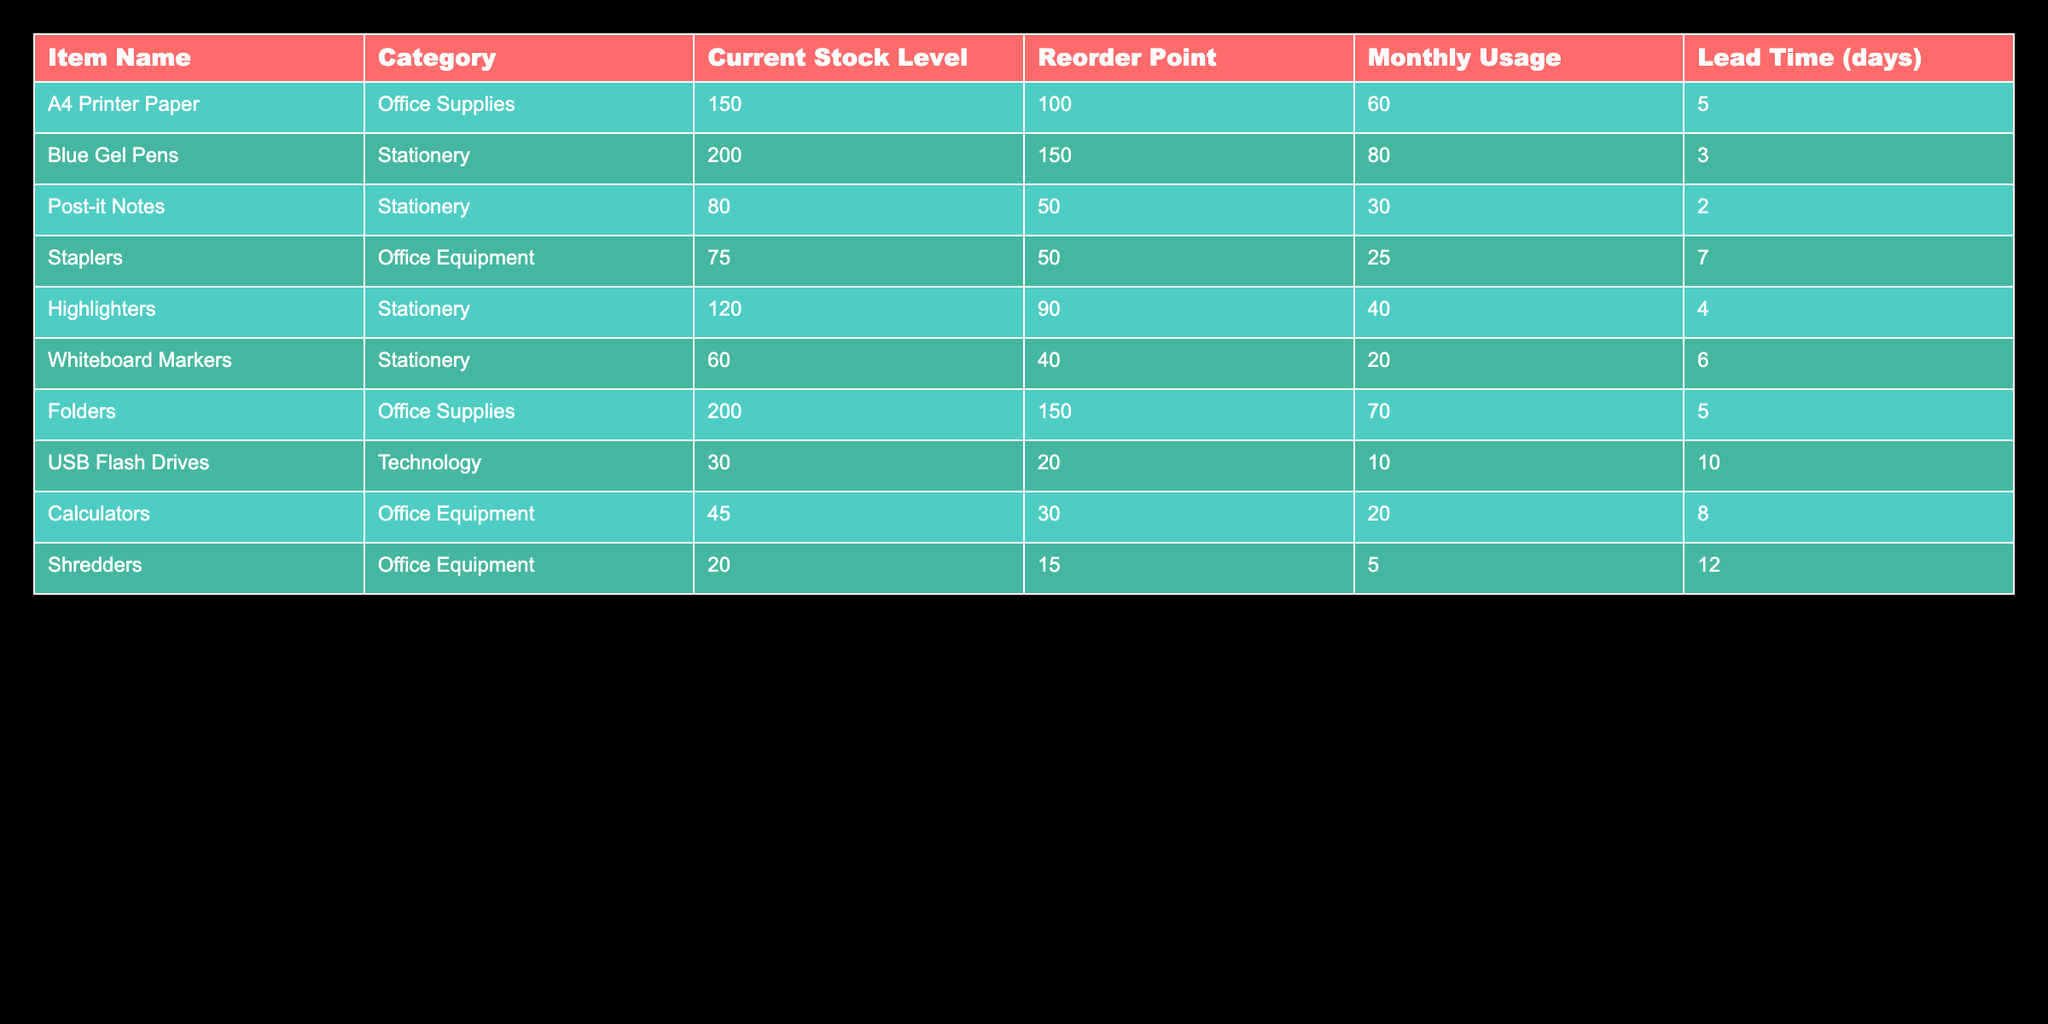What is the current stock level of Blue Gel Pens? The table lists Blue Gel Pens under the Item Name and shows the Current Stock Level in the corresponding column. The value there is 200.
Answer: 200 Is the current stock level of A4 Printer Paper above its reorder point? The current stock level for A4 Printer Paper is 150, and its reorder point is 100. Since 150 is greater than 100, it indicates that the stock level is above the reorder point.
Answer: Yes What is the total monthly usage of all Office Equipment items? There are three items categorized as Office Equipment: Staplers (25), Calculators (20), and Shredders (5). Adding them together gives total monthly usage: 25 + 20 + 5 = 50.
Answer: 50 How many items have a current stock level less than their reorder point? First, we check each item’s current stock level against its reorder point. Staplers (75 vs. 50), USB Flash Drives (30 vs. 20), Calculators (45 vs. 30), and Shredders (20 vs. 15) meet the criterion. Shredders are the only item below its reorder point, so the total number of items below the reorder point is one.
Answer: 1 What is the average monthly usage of Stationery items? The Stationery items are Blue Gel Pens (80), Post-it Notes (30), Highlighters (40), and Whiteboard Markers (20). First, we sum them: 80 + 30 + 40 + 20 = 170. Next, we divide the total by the number of items, which is 4: 170 / 4 = 42.5.
Answer: 42.5 